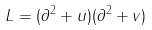Convert formula to latex. <formula><loc_0><loc_0><loc_500><loc_500>L = ( \partial ^ { 2 } + u ) ( \partial ^ { 2 } + v )</formula> 